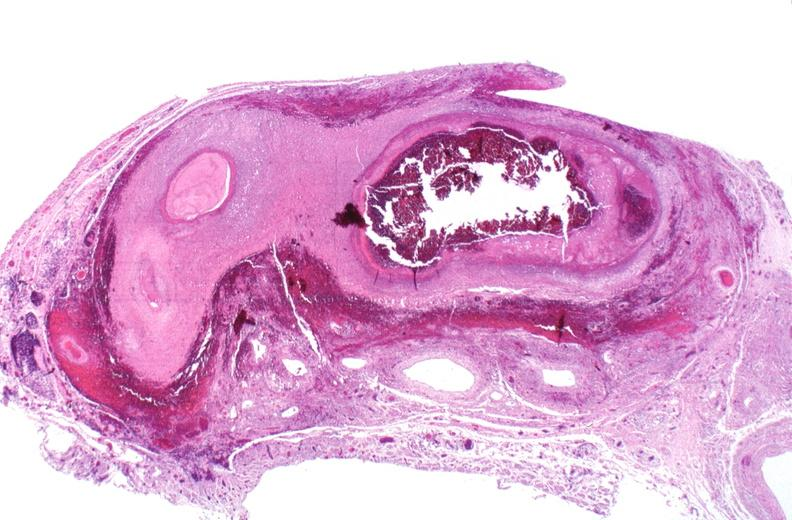s muscle atrophy present?
Answer the question using a single word or phrase. No 